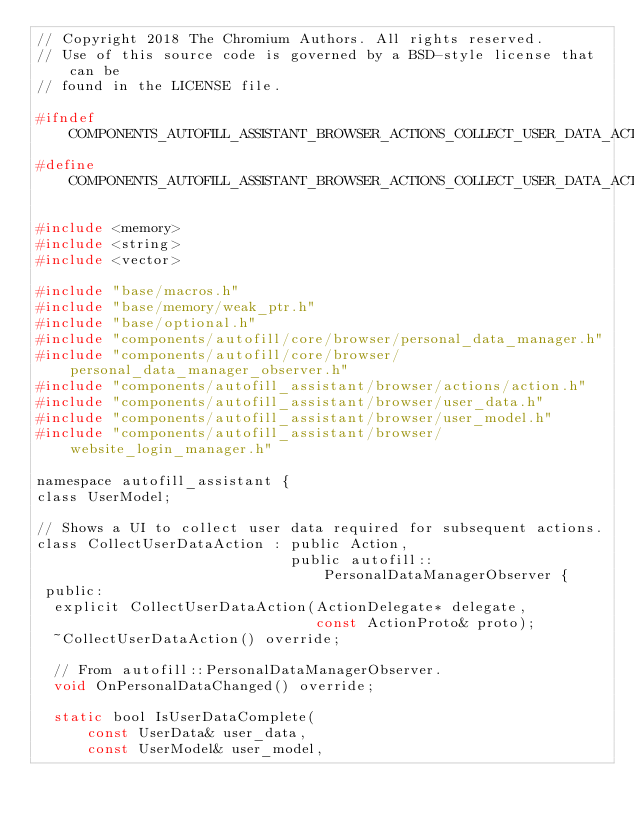Convert code to text. <code><loc_0><loc_0><loc_500><loc_500><_C_>// Copyright 2018 The Chromium Authors. All rights reserved.
// Use of this source code is governed by a BSD-style license that can be
// found in the LICENSE file.

#ifndef COMPONENTS_AUTOFILL_ASSISTANT_BROWSER_ACTIONS_COLLECT_USER_DATA_ACTION_H_
#define COMPONENTS_AUTOFILL_ASSISTANT_BROWSER_ACTIONS_COLLECT_USER_DATA_ACTION_H_

#include <memory>
#include <string>
#include <vector>

#include "base/macros.h"
#include "base/memory/weak_ptr.h"
#include "base/optional.h"
#include "components/autofill/core/browser/personal_data_manager.h"
#include "components/autofill/core/browser/personal_data_manager_observer.h"
#include "components/autofill_assistant/browser/actions/action.h"
#include "components/autofill_assistant/browser/user_data.h"
#include "components/autofill_assistant/browser/user_model.h"
#include "components/autofill_assistant/browser/website_login_manager.h"

namespace autofill_assistant {
class UserModel;

// Shows a UI to collect user data required for subsequent actions.
class CollectUserDataAction : public Action,
                              public autofill::PersonalDataManagerObserver {
 public:
  explicit CollectUserDataAction(ActionDelegate* delegate,
                                 const ActionProto& proto);
  ~CollectUserDataAction() override;

  // From autofill::PersonalDataManagerObserver.
  void OnPersonalDataChanged() override;

  static bool IsUserDataComplete(
      const UserData& user_data,
      const UserModel& user_model,</code> 